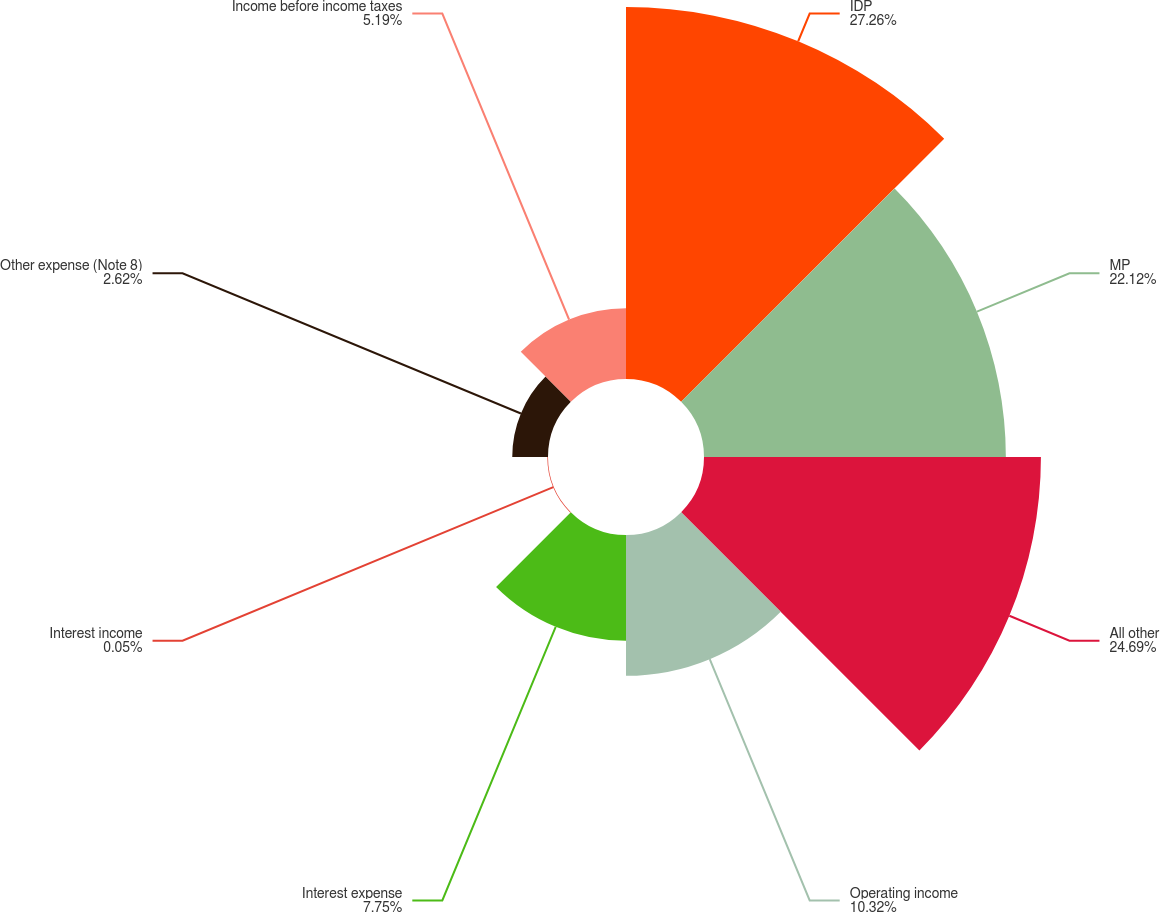Convert chart to OTSL. <chart><loc_0><loc_0><loc_500><loc_500><pie_chart><fcel>IDP<fcel>MP<fcel>All other<fcel>Operating income<fcel>Interest expense<fcel>Interest income<fcel>Other expense (Note 8)<fcel>Income before income taxes<nl><fcel>27.26%<fcel>22.12%<fcel>24.69%<fcel>10.32%<fcel>7.75%<fcel>0.05%<fcel>2.62%<fcel>5.19%<nl></chart> 